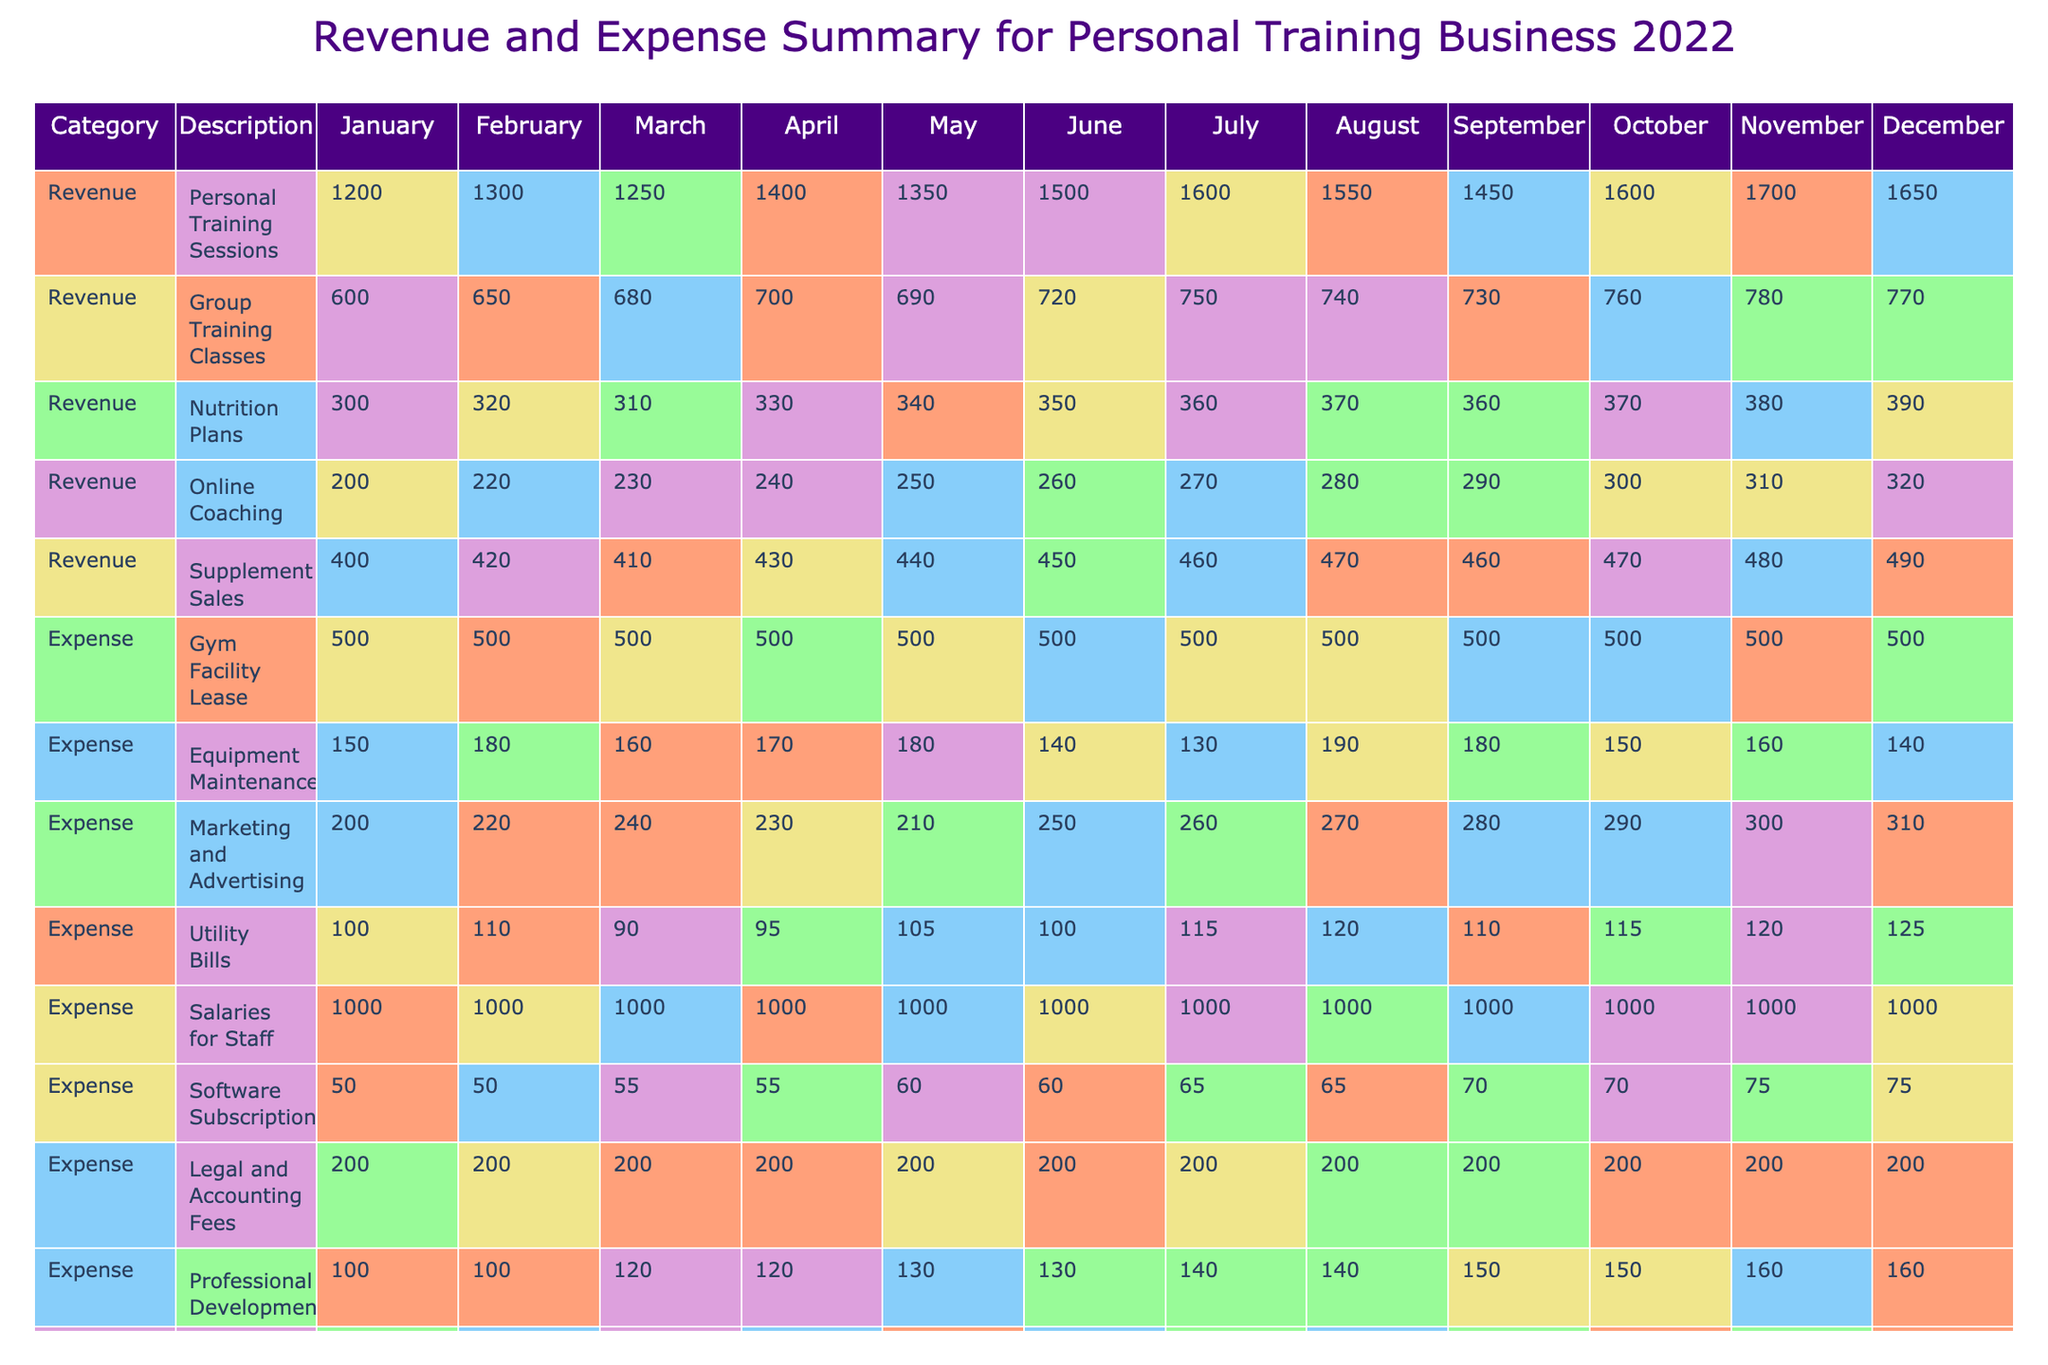What was the total revenue from personal training sessions in December? In December, the revenue from personal training sessions is listed as 1650. This value is directly found in the row for "Personal Training Sessions" under the December column.
Answer: 1650 What is the average monthly expense for the gym facility lease? The gym facility lease has a constant monthly expense of 500 throughout the year. Thus, the average monthly expense is the same, which is 500.
Answer: 500 Did the revenue from online coaching increase every month? By examining the monthly revenue values for online coaching, they are: 200, 220, 230, 240, 250, 260, 270, 280, 290, 300, 310, 320. All values show a consistent increase from January to December, confirming the revenue increase every month.
Answer: Yes What is the net profit for the month with the highest revenue? First, identify the month with the highest revenue, which is December, then look for the net profit for that month. The values for December are total revenue of 3620 and total expenses of 2510. The net profit for December is calculated as 3620 - 2510 = 1110.
Answer: 1110 What was the total revenue and total expense in June? In June, the total revenue is 3280 and the total expenses are 2380. These values can be found directly in the table under the June column for both the total revenue and total expenses rows.
Answer: Revenue: 3280, Expenses: 2380 Which month had the lowest net profit and what was it? To find the lowest net profit, we check the net profits for each month: 400, 530, 515, 730, 685, 900, 1030, 925, 800, 1025, 1135, 1110. The lowest value is 400, which occurs in January.
Answer: January: 400 How much did the equipment maintenance expenses fluctuate throughout the year? The equipment maintenance expenses are: 150, 180, 160, 170, 180, 140, 130, 190, 180, 150, 160, 140. Fluctuation can be assessed by the difference between the maximum (190) and minimum (130) values: 190 - 130 = 60. Hence, the expenses fluctuated by 60 throughout the year.
Answer: 60 Was the revenue from group training classes greater than nutrition plans every month? By comparing the revenues month by month, we have group training classes: 600, 650, 680, 700, 690, 720, 750, 740, 730, 760, 780, 770 and nutrition plans: 300, 320, 310, 330, 340, 350, 360, 370, 360, 370, 380, 390. In every month, the revenue from group training classes is greater than that of nutrition plans.
Answer: Yes 